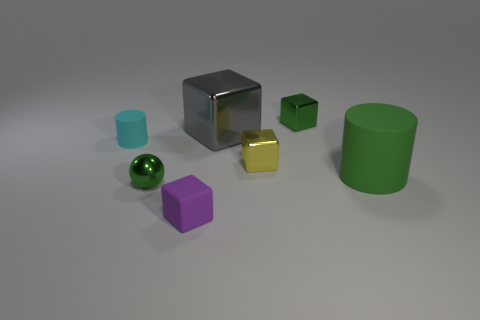Are there more big green matte cylinders than matte cylinders?
Ensure brevity in your answer.  No. How many other things are the same color as the sphere?
Provide a succinct answer. 2. How many objects are behind the green rubber object and left of the small yellow shiny thing?
Offer a terse response. 2. Is the number of green shiny objects to the right of the sphere greater than the number of spheres right of the big shiny block?
Ensure brevity in your answer.  Yes. There is a small green object behind the tiny cylinder; what is it made of?
Offer a terse response. Metal. Does the yellow thing have the same shape as the green shiny object behind the tiny cylinder?
Ensure brevity in your answer.  Yes. There is a small green object left of the small green object on the right side of the purple matte cube; what number of large green rubber objects are in front of it?
Your answer should be very brief. 0. The other big shiny object that is the same shape as the purple object is what color?
Make the answer very short. Gray. Is there any other thing that is the same shape as the cyan thing?
Your answer should be very brief. Yes. How many cylinders are either big brown shiny things or small shiny things?
Offer a terse response. 0. 